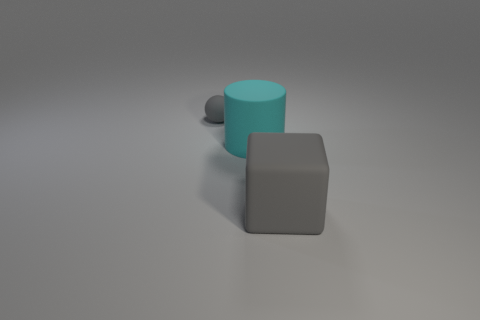The thing that is both behind the large block and in front of the tiny gray object has what shape?
Provide a short and direct response. Cylinder. Are there the same number of cyan matte cylinders in front of the big rubber block and yellow matte cylinders?
Offer a terse response. Yes. What number of things are either large yellow spheres or matte things behind the big cyan cylinder?
Provide a succinct answer. 1. Are there the same number of tiny matte things that are behind the small gray ball and gray blocks to the left of the big gray object?
Offer a terse response. Yes. Is there anything else that is the same size as the gray matte sphere?
Make the answer very short. No. How many brown objects are big matte cylinders or spheres?
Your response must be concise. 0. How many rubber blocks have the same size as the cyan cylinder?
Keep it short and to the point. 1. Is the number of gray rubber balls behind the cyan cylinder greater than the number of large purple matte objects?
Your response must be concise. Yes. Are there any small blue things?
Offer a terse response. No. Does the tiny sphere have the same color as the rubber cube?
Offer a terse response. Yes. 